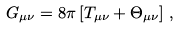<formula> <loc_0><loc_0><loc_500><loc_500>G _ { \mu \nu } = 8 \pi \left [ T _ { \mu \nu } + \Theta _ { \mu \nu } \right ] \, ,</formula> 